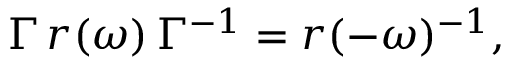Convert formula to latex. <formula><loc_0><loc_0><loc_500><loc_500>\begin{array} { r } { \Gamma \, r ( \omega ) \, \Gamma ^ { - 1 } = r ( - \omega ) ^ { - 1 } , } \end{array}</formula> 